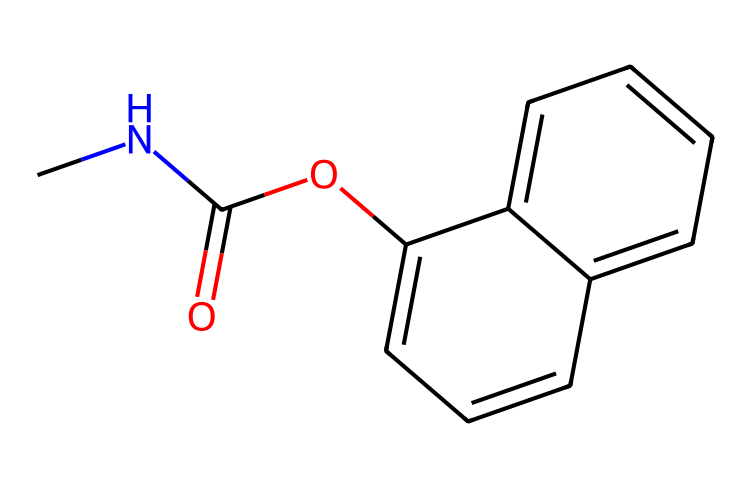What is the chemical name of this structure? The SMILES representation corresponds to carbaryl, which is a commonly used pesticide in home gardens and orchards.
Answer: carbaryl How many carbon atoms are in this molecule? By analyzing the SMILES, we find that 'C' appears numerous times, and counting each 'C' gives us 11 carbon atoms in total.
Answer: 11 What functional group is present in carbaryl? The presence of 'C(=O)' in the structure indicates that it contains a carbonyl group, which is part of an ester in this case.
Answer: carbonyl What is the total number of nitrogen atoms in carbaryl? The SMILES shows 'N' appears only once in the structure, indicating there is one nitrogen atom in carbaryl.
Answer: 1 How many rings are in the molecular structure of carbaryl? The rings can be identified in the chemical structure indicated by 'c' which represents aromatic carbons. There are two interconnected rings present.
Answer: 2 What type of pesticide is carbaryl classified as? Carbaryl is classified as a carbamate insecticide, based on its chemical structure and functional groups involved in its mechanism of action.
Answer: carbamate Is carbaryl likely to be a systemic or contact pesticide? Carbaryl is primarily a contact pesticide, meaning it acts upon direct contact with pests, as indicated by its chemical structure and action method.
Answer: contact 